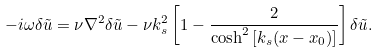Convert formula to latex. <formula><loc_0><loc_0><loc_500><loc_500>- i \omega \delta \tilde { u } = \nu \nabla ^ { 2 } \delta \tilde { u } - \nu k ^ { 2 } _ { s } \left [ 1 - \frac { 2 } { \cosh ^ { 2 } { [ k _ { s } ( x - x _ { 0 } ) ] } } \right ] \delta \tilde { u } .</formula> 